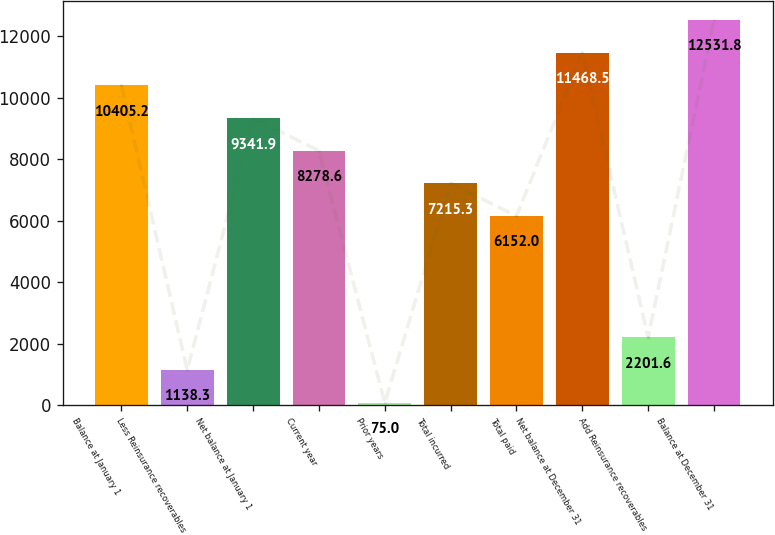Convert chart. <chart><loc_0><loc_0><loc_500><loc_500><bar_chart><fcel>Balance at January 1<fcel>Less Reinsurance recoverables<fcel>Net balance at January 1<fcel>Current year<fcel>Prior years<fcel>Total incurred<fcel>Total paid<fcel>Net balance at December 31<fcel>Add Reinsurance recoverables<fcel>Balance at December 31<nl><fcel>10405.2<fcel>1138.3<fcel>9341.9<fcel>8278.6<fcel>75<fcel>7215.3<fcel>6152<fcel>11468.5<fcel>2201.6<fcel>12531.8<nl></chart> 